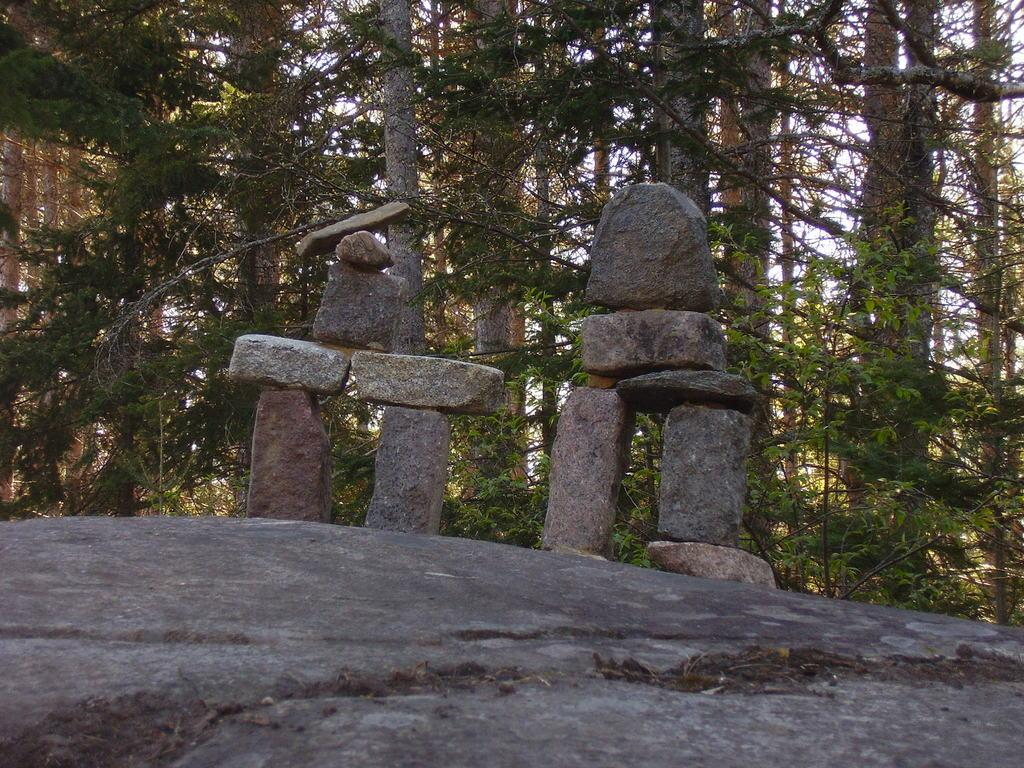What type of natural elements can be seen in the image? There are rocks and trees in the image. Can you describe the rocks in the image? The rocks in the image are visible and are part of the natural landscape. What type of vegetation is present in the image? There are trees in the image, which are a type of vegetation. Is there a stream of power running through the quiver of rocks in the image? There is no mention of a stream of power or a quiver of rocks in the image. The image only contains rocks and trees. 